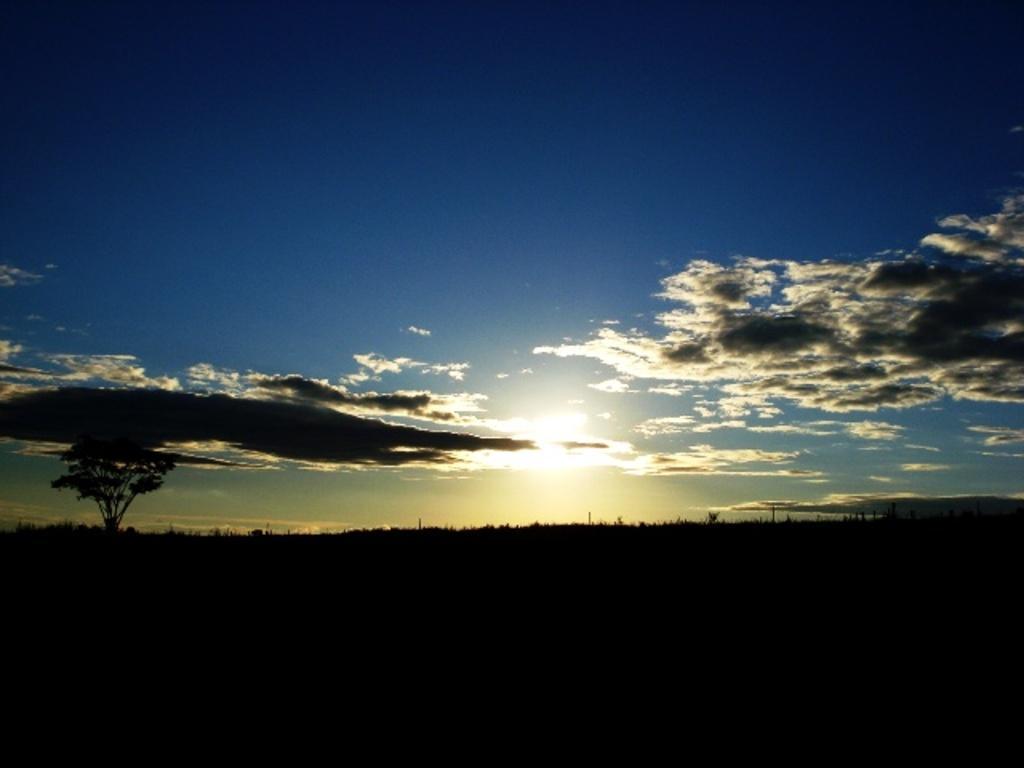How would you summarize this image in a sentence or two? In this picture, it seems to be there is greenery at the bottom side and there is sky in the center of the image. 